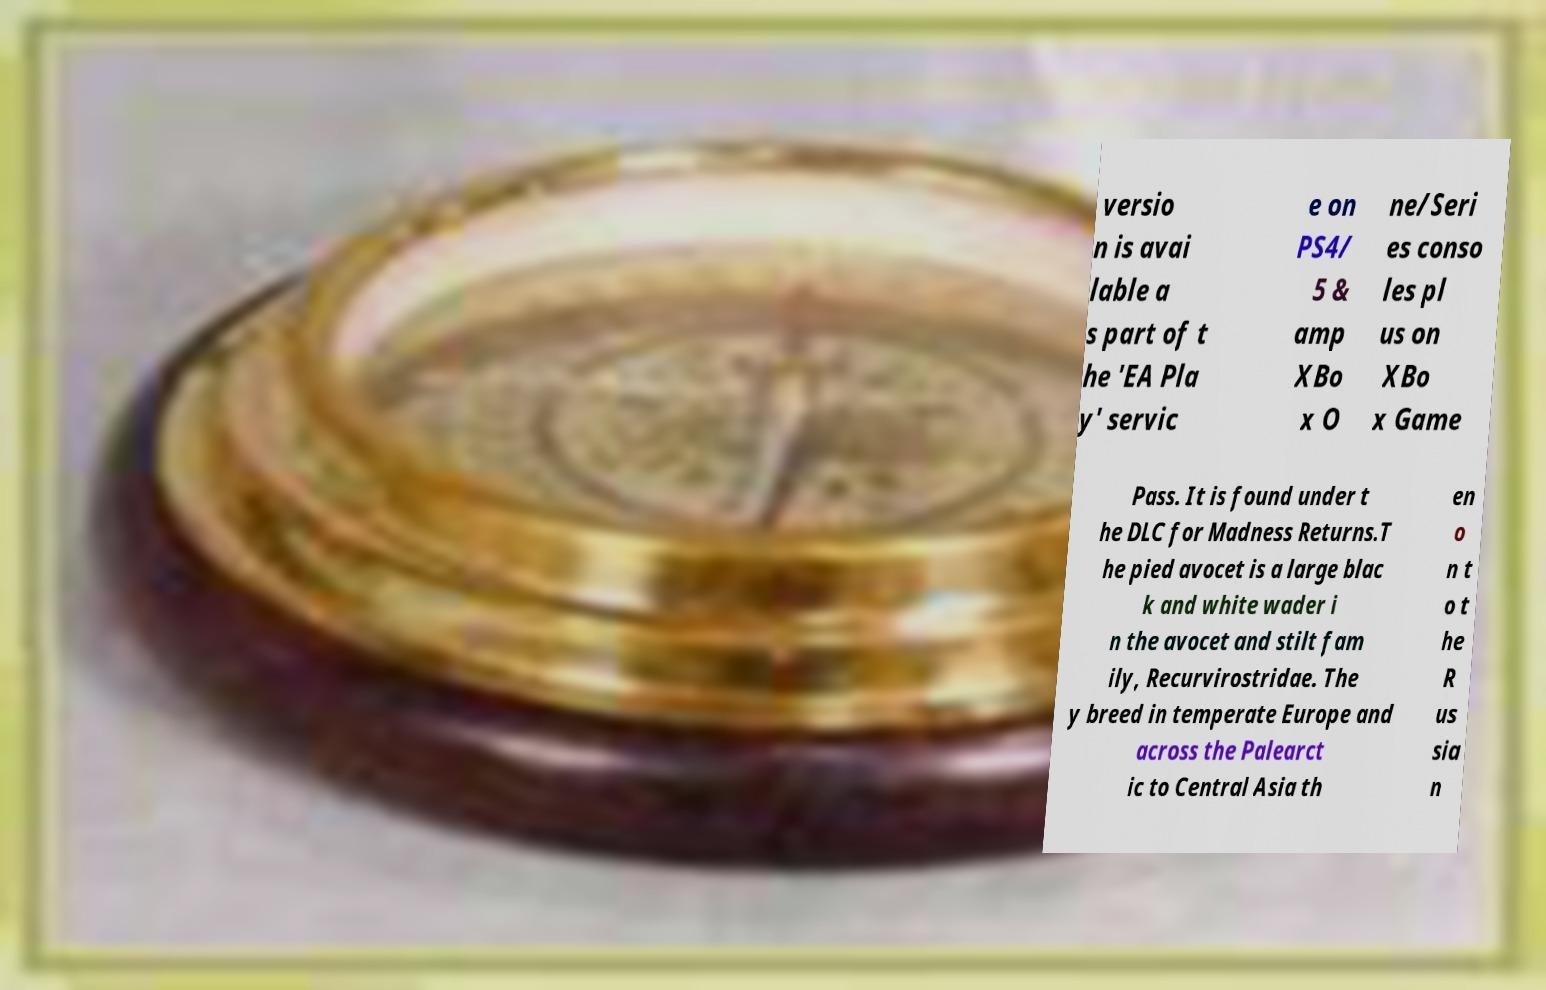What messages or text are displayed in this image? I need them in a readable, typed format. versio n is avai lable a s part of t he 'EA Pla y' servic e on PS4/ 5 & amp XBo x O ne/Seri es conso les pl us on XBo x Game Pass. It is found under t he DLC for Madness Returns.T he pied avocet is a large blac k and white wader i n the avocet and stilt fam ily, Recurvirostridae. The y breed in temperate Europe and across the Palearct ic to Central Asia th en o n t o t he R us sia n 